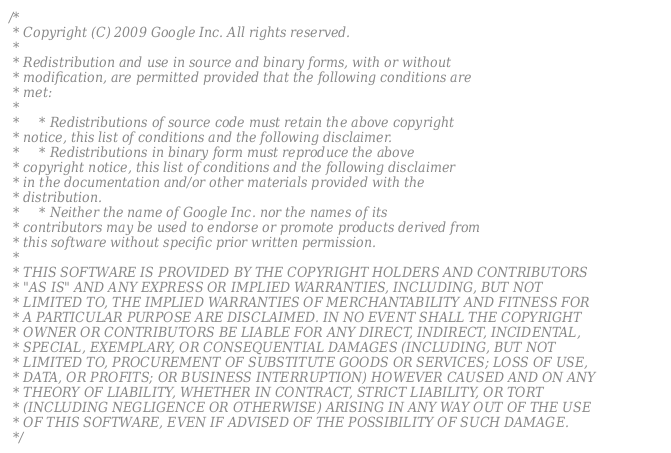Convert code to text. <code><loc_0><loc_0><loc_500><loc_500><_C++_>/*
 * Copyright (C) 2009 Google Inc. All rights reserved.
 *
 * Redistribution and use in source and binary forms, with or without
 * modification, are permitted provided that the following conditions are
 * met:
 *
 *     * Redistributions of source code must retain the above copyright
 * notice, this list of conditions and the following disclaimer.
 *     * Redistributions in binary form must reproduce the above
 * copyright notice, this list of conditions and the following disclaimer
 * in the documentation and/or other materials provided with the
 * distribution.
 *     * Neither the name of Google Inc. nor the names of its
 * contributors may be used to endorse or promote products derived from
 * this software without specific prior written permission.
 *
 * THIS SOFTWARE IS PROVIDED BY THE COPYRIGHT HOLDERS AND CONTRIBUTORS
 * "AS IS" AND ANY EXPRESS OR IMPLIED WARRANTIES, INCLUDING, BUT NOT
 * LIMITED TO, THE IMPLIED WARRANTIES OF MERCHANTABILITY AND FITNESS FOR
 * A PARTICULAR PURPOSE ARE DISCLAIMED. IN NO EVENT SHALL THE COPYRIGHT
 * OWNER OR CONTRIBUTORS BE LIABLE FOR ANY DIRECT, INDIRECT, INCIDENTAL,
 * SPECIAL, EXEMPLARY, OR CONSEQUENTIAL DAMAGES (INCLUDING, BUT NOT
 * LIMITED TO, PROCUREMENT OF SUBSTITUTE GOODS OR SERVICES; LOSS OF USE,
 * DATA, OR PROFITS; OR BUSINESS INTERRUPTION) HOWEVER CAUSED AND ON ANY
 * THEORY OF LIABILITY, WHETHER IN CONTRACT, STRICT LIABILITY, OR TORT
 * (INCLUDING NEGLIGENCE OR OTHERWISE) ARISING IN ANY WAY OUT OF THE USE
 * OF THIS SOFTWARE, EVEN IF ADVISED OF THE POSSIBILITY OF SUCH DAMAGE.
 */
</code> 